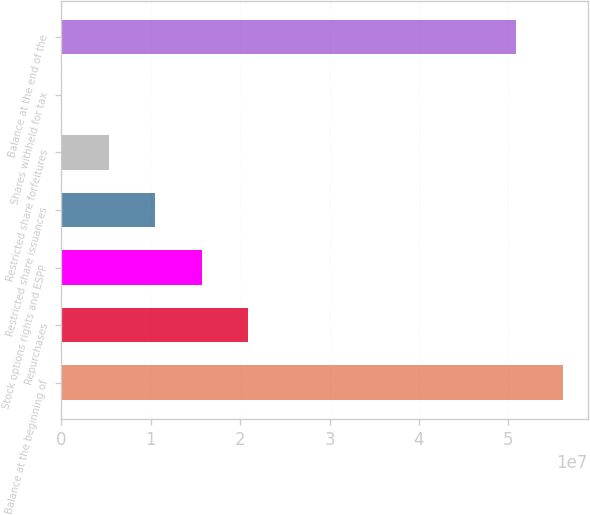Convert chart to OTSL. <chart><loc_0><loc_0><loc_500><loc_500><bar_chart><fcel>Balance at the beginning of<fcel>Repurchases<fcel>Stock options rights and ESPP<fcel>Restricted share issuances<fcel>Restricted share forfeitures<fcel>Shares withheld for tax<fcel>Balance at the end of the<nl><fcel>5.61106e+07<fcel>2.08811e+07<fcel>1.56788e+07<fcel>1.04765e+07<fcel>5.27412e+06<fcel>71780<fcel>5.09083e+07<nl></chart> 